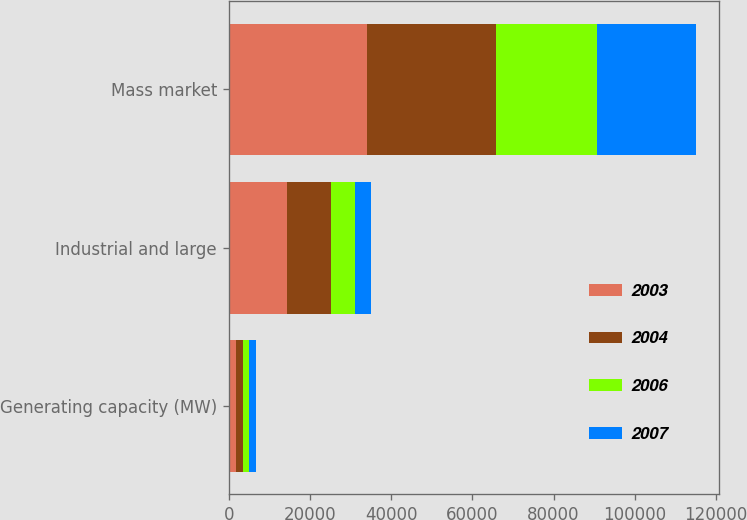<chart> <loc_0><loc_0><loc_500><loc_500><stacked_bar_chart><ecel><fcel>Generating capacity (MW)<fcel>Industrial and large<fcel>Mass market<nl><fcel>2003<fcel>1739<fcel>14335<fcel>33979<nl><fcel>2004<fcel>1668<fcel>10957<fcel>31725<nl><fcel>2006<fcel>1668<fcel>5775<fcel>24989<nl><fcel>2007<fcel>1668<fcel>3913<fcel>24242<nl></chart> 